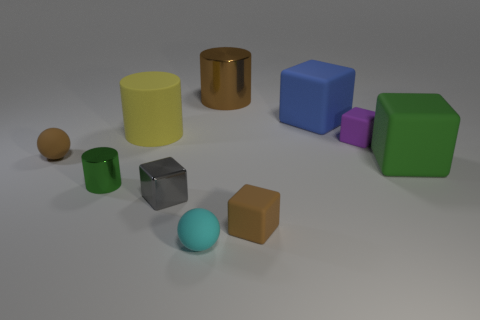Subtract all big rubber cylinders. How many cylinders are left? 2 Subtract all spheres. How many objects are left? 8 Subtract 1 spheres. How many spheres are left? 1 Subtract all gray cubes. How many cubes are left? 4 Subtract all green blocks. Subtract all red cylinders. How many blocks are left? 4 Subtract all yellow cylinders. How many blue balls are left? 0 Subtract all tiny purple cubes. Subtract all cyan balls. How many objects are left? 8 Add 5 tiny brown matte spheres. How many tiny brown matte spheres are left? 6 Add 6 large blue rubber blocks. How many large blue rubber blocks exist? 7 Subtract 1 brown cubes. How many objects are left? 9 